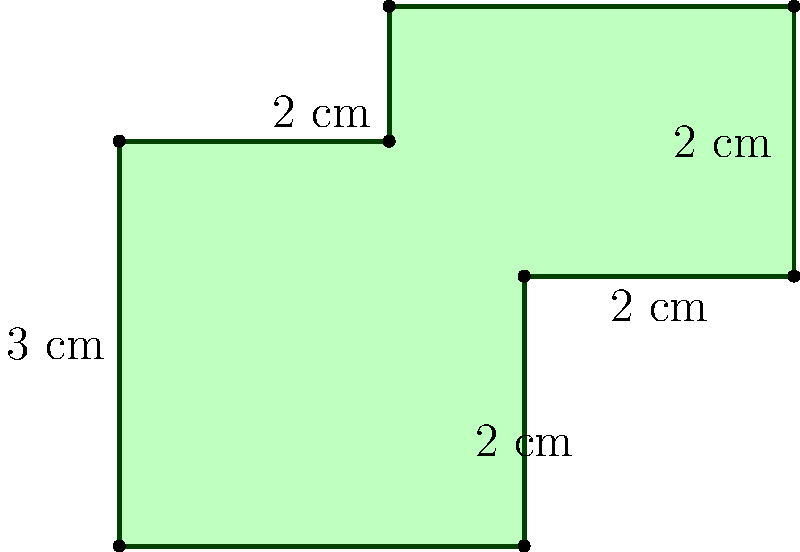Mamma mia! You've just created a new pasta shape for your food blog. The outline of this unique pasta noodle is shown in the diagram above. If each small square in the grid represents 1 cm, what is the perimeter of this pasta-inspired shape in centimeters? Let's calculate the perimeter by adding up the lengths of all sides:

1. Bottom edge: 3 cm
2. Right side (bottom part): 2 cm
3. Small horizontal piece on the right: 2 cm
4. Right side (top part): 2 cm
5. Top edge: 3 cm
6. Left side (top part): 1 cm
7. Small horizontal piece on the left: 2 cm
8. Left side (bottom part): 3 cm

Now, let's sum up all these lengths:

$$ 3 + 2 + 2 + 2 + 3 + 1 + 2 + 3 = 18 \text{ cm} $$

Therefore, the perimeter of this pasta-shaped noodle is 18 cm.
Answer: 18 cm 